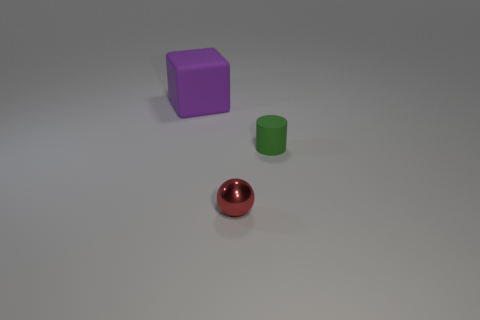Add 3 tiny gray cylinders. How many objects exist? 6 Subtract all red spheres. Subtract all tiny red things. How many objects are left? 1 Add 1 red metallic objects. How many red metallic objects are left? 2 Add 2 tiny things. How many tiny things exist? 4 Subtract 0 purple spheres. How many objects are left? 3 Subtract all balls. How many objects are left? 2 Subtract all cyan blocks. Subtract all cyan balls. How many blocks are left? 1 